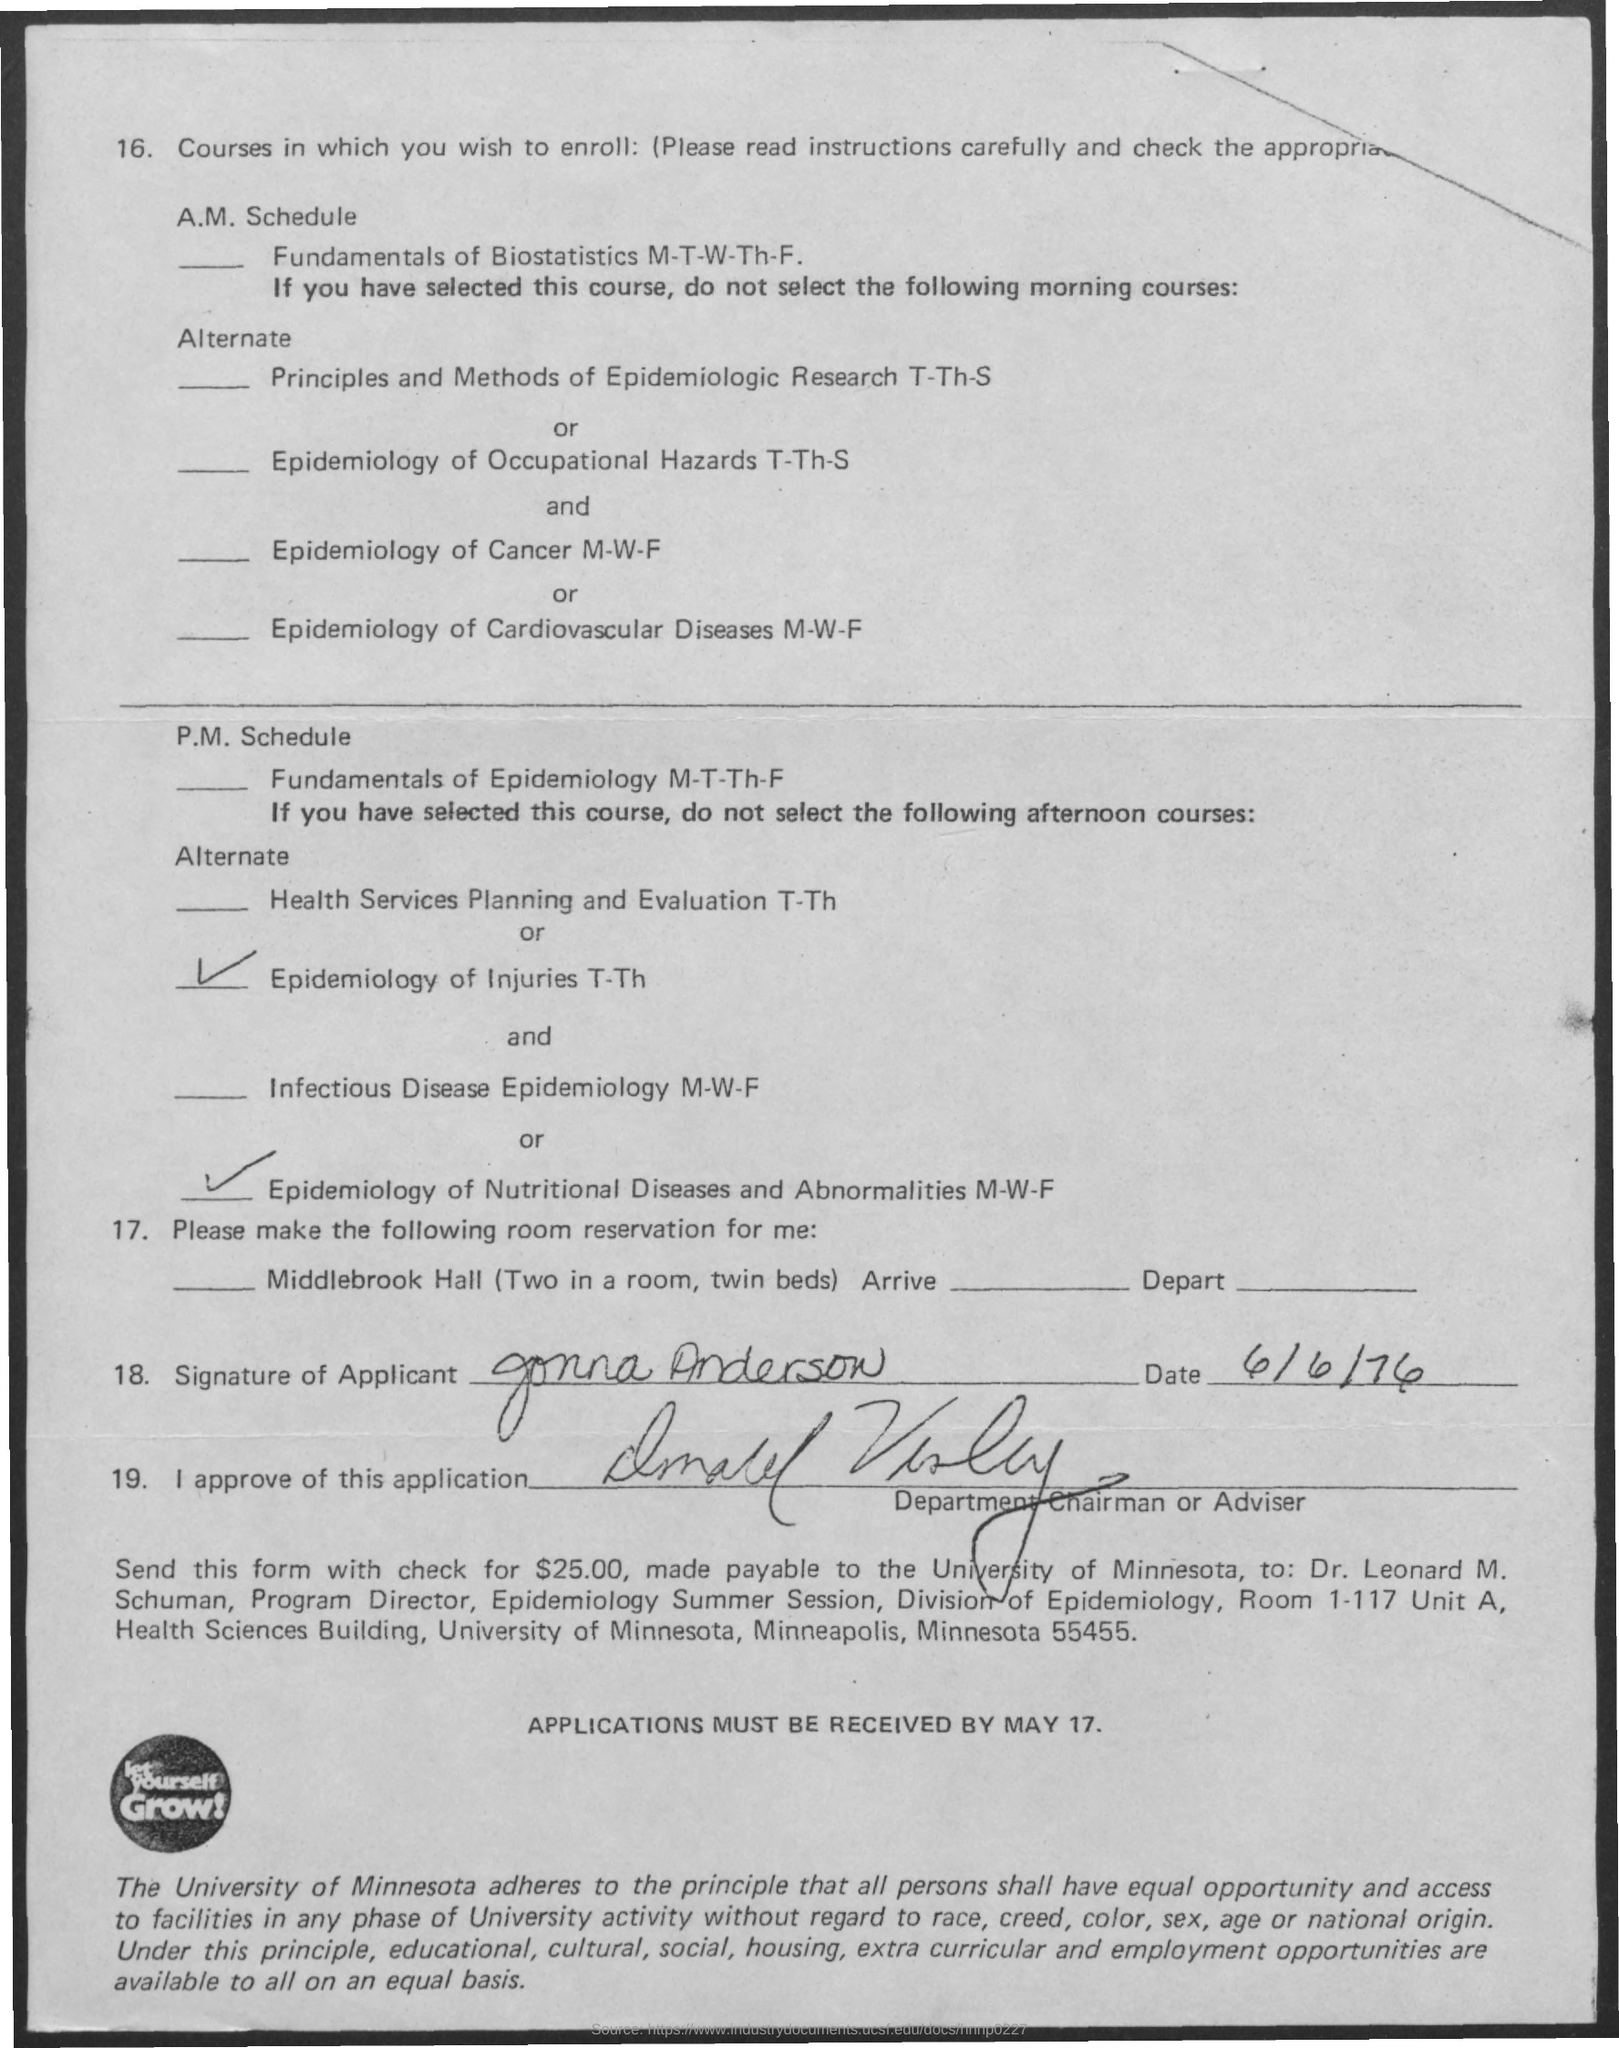Mention a couple of crucial points in this snapshot. The date on the document is June 6th, 1976. 